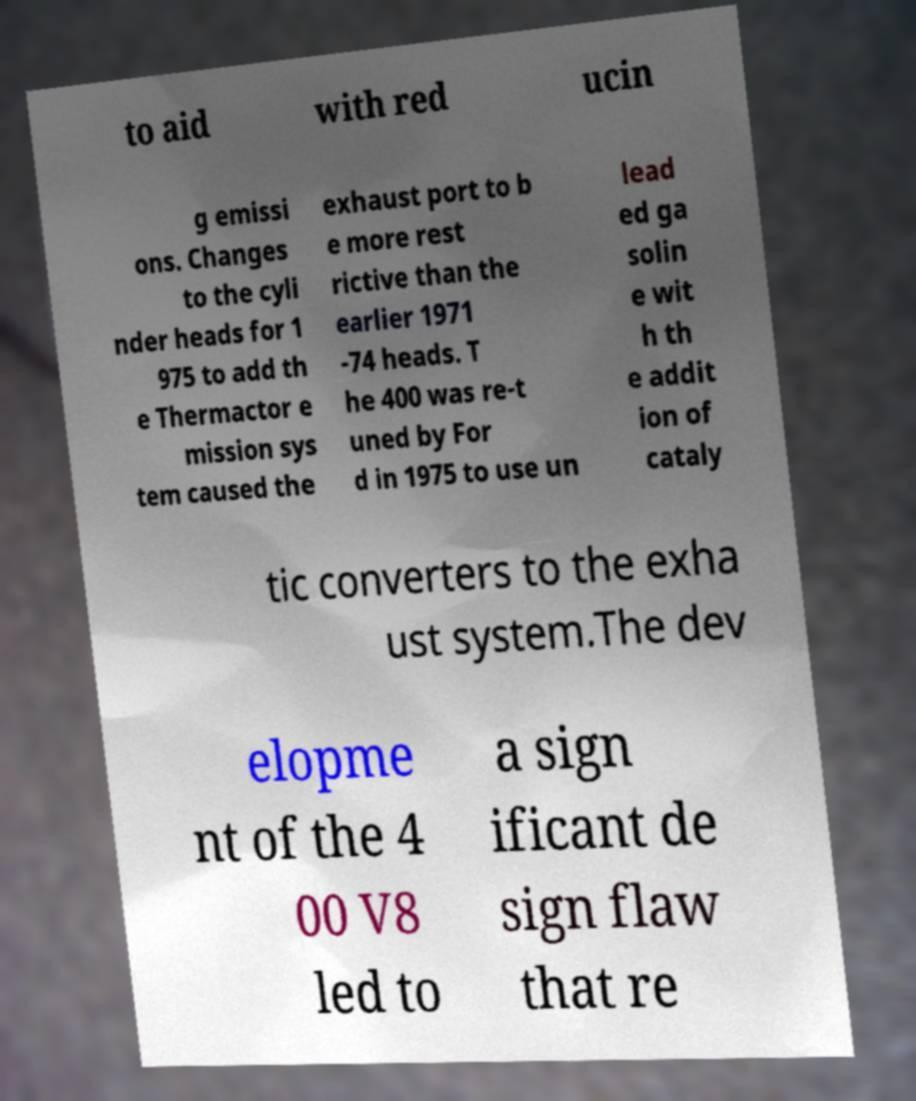Please read and relay the text visible in this image. What does it say? to aid with red ucin g emissi ons. Changes to the cyli nder heads for 1 975 to add th e Thermactor e mission sys tem caused the exhaust port to b e more rest rictive than the earlier 1971 -74 heads. T he 400 was re-t uned by For d in 1975 to use un lead ed ga solin e wit h th e addit ion of cataly tic converters to the exha ust system.The dev elopme nt of the 4 00 V8 led to a sign ificant de sign flaw that re 